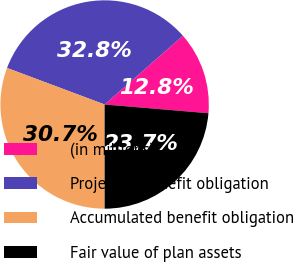<chart> <loc_0><loc_0><loc_500><loc_500><pie_chart><fcel>(in millions)<fcel>Projected benefit obligation<fcel>Accumulated benefit obligation<fcel>Fair value of plan assets<nl><fcel>12.8%<fcel>32.83%<fcel>30.71%<fcel>23.66%<nl></chart> 